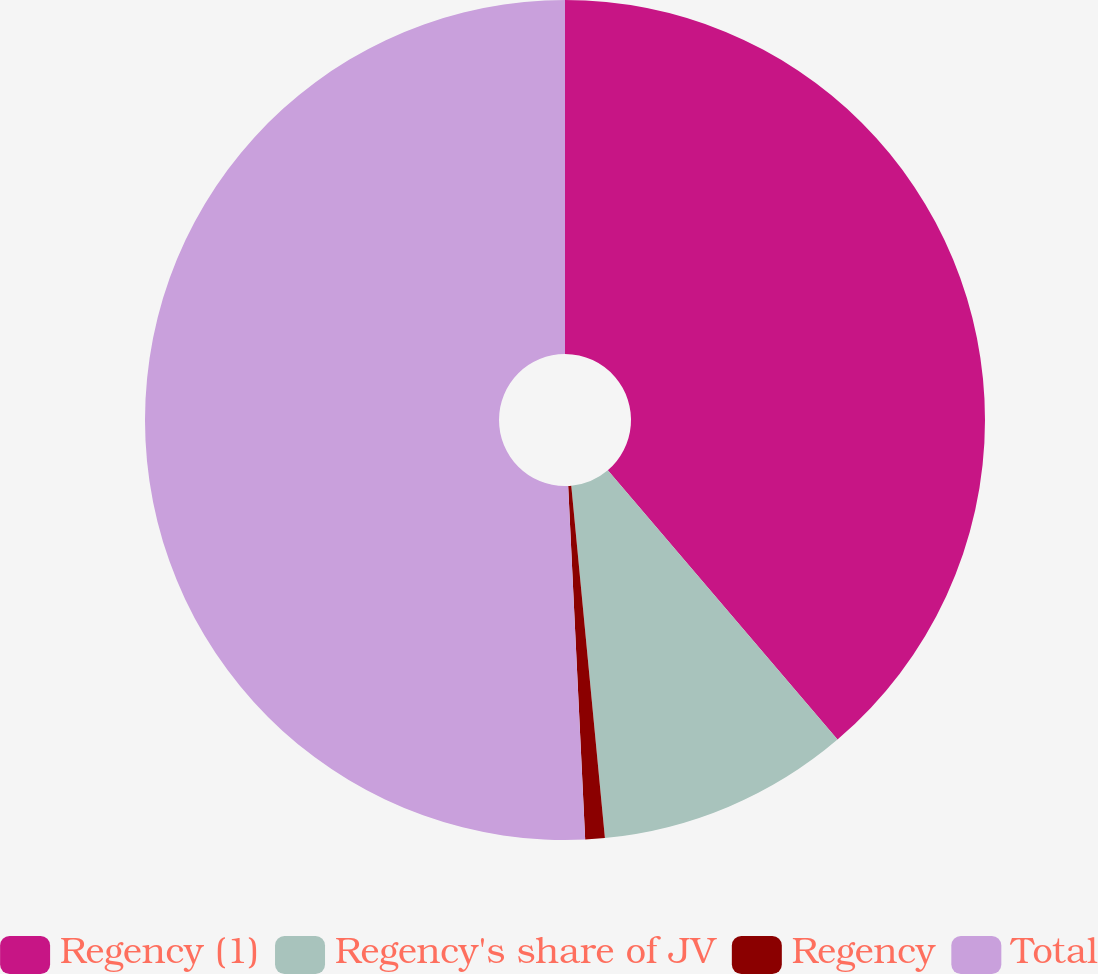Convert chart to OTSL. <chart><loc_0><loc_0><loc_500><loc_500><pie_chart><fcel>Regency (1)<fcel>Regency's share of JV<fcel>Regency<fcel>Total<nl><fcel>38.76%<fcel>9.72%<fcel>0.75%<fcel>50.76%<nl></chart> 